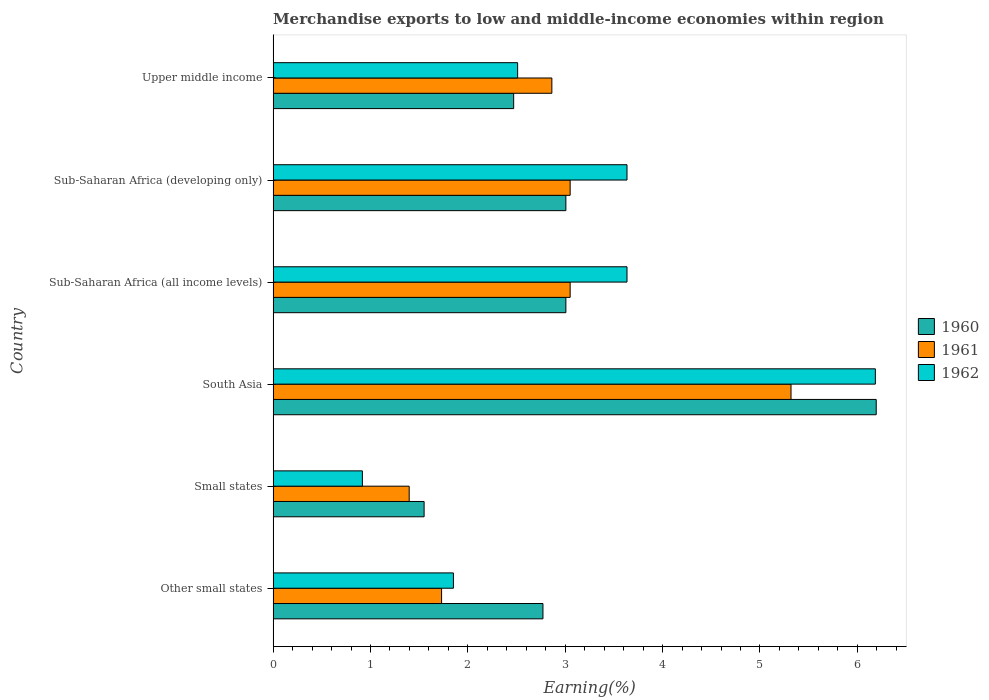How many groups of bars are there?
Your response must be concise. 6. What is the label of the 5th group of bars from the top?
Make the answer very short. Small states. What is the percentage of amount earned from merchandise exports in 1960 in Sub-Saharan Africa (all income levels)?
Offer a terse response. 3.01. Across all countries, what is the maximum percentage of amount earned from merchandise exports in 1961?
Offer a very short reply. 5.32. Across all countries, what is the minimum percentage of amount earned from merchandise exports in 1961?
Your response must be concise. 1.4. In which country was the percentage of amount earned from merchandise exports in 1961 minimum?
Your response must be concise. Small states. What is the total percentage of amount earned from merchandise exports in 1962 in the graph?
Your response must be concise. 18.73. What is the difference between the percentage of amount earned from merchandise exports in 1962 in Small states and that in Sub-Saharan Africa (developing only)?
Offer a terse response. -2.72. What is the difference between the percentage of amount earned from merchandise exports in 1962 in Upper middle income and the percentage of amount earned from merchandise exports in 1960 in Sub-Saharan Africa (all income levels)?
Keep it short and to the point. -0.5. What is the average percentage of amount earned from merchandise exports in 1961 per country?
Your answer should be compact. 2.9. What is the difference between the percentage of amount earned from merchandise exports in 1961 and percentage of amount earned from merchandise exports in 1960 in Other small states?
Provide a succinct answer. -1.04. What is the ratio of the percentage of amount earned from merchandise exports in 1960 in South Asia to that in Upper middle income?
Offer a very short reply. 2.51. Is the percentage of amount earned from merchandise exports in 1962 in Sub-Saharan Africa (all income levels) less than that in Sub-Saharan Africa (developing only)?
Offer a very short reply. No. Is the difference between the percentage of amount earned from merchandise exports in 1961 in South Asia and Sub-Saharan Africa (developing only) greater than the difference between the percentage of amount earned from merchandise exports in 1960 in South Asia and Sub-Saharan Africa (developing only)?
Your response must be concise. No. What is the difference between the highest and the second highest percentage of amount earned from merchandise exports in 1960?
Your response must be concise. 3.19. What is the difference between the highest and the lowest percentage of amount earned from merchandise exports in 1962?
Provide a succinct answer. 5.27. Is the sum of the percentage of amount earned from merchandise exports in 1962 in Other small states and Sub-Saharan Africa (developing only) greater than the maximum percentage of amount earned from merchandise exports in 1961 across all countries?
Ensure brevity in your answer.  Yes. What does the 2nd bar from the top in Other small states represents?
Your response must be concise. 1961. What does the 1st bar from the bottom in Sub-Saharan Africa (developing only) represents?
Give a very brief answer. 1960. Is it the case that in every country, the sum of the percentage of amount earned from merchandise exports in 1961 and percentage of amount earned from merchandise exports in 1962 is greater than the percentage of amount earned from merchandise exports in 1960?
Provide a short and direct response. Yes. Are all the bars in the graph horizontal?
Ensure brevity in your answer.  Yes. Does the graph contain any zero values?
Keep it short and to the point. No. Does the graph contain grids?
Make the answer very short. No. Where does the legend appear in the graph?
Provide a short and direct response. Center right. How many legend labels are there?
Provide a short and direct response. 3. How are the legend labels stacked?
Keep it short and to the point. Vertical. What is the title of the graph?
Offer a very short reply. Merchandise exports to low and middle-income economies within region. What is the label or title of the X-axis?
Provide a succinct answer. Earning(%). What is the label or title of the Y-axis?
Provide a succinct answer. Country. What is the Earning(%) in 1960 in Other small states?
Keep it short and to the point. 2.77. What is the Earning(%) in 1961 in Other small states?
Give a very brief answer. 1.73. What is the Earning(%) of 1962 in Other small states?
Your answer should be very brief. 1.85. What is the Earning(%) of 1960 in Small states?
Ensure brevity in your answer.  1.55. What is the Earning(%) in 1961 in Small states?
Ensure brevity in your answer.  1.4. What is the Earning(%) of 1962 in Small states?
Offer a very short reply. 0.92. What is the Earning(%) of 1960 in South Asia?
Offer a terse response. 6.19. What is the Earning(%) in 1961 in South Asia?
Make the answer very short. 5.32. What is the Earning(%) in 1962 in South Asia?
Provide a short and direct response. 6.19. What is the Earning(%) in 1960 in Sub-Saharan Africa (all income levels)?
Make the answer very short. 3.01. What is the Earning(%) of 1961 in Sub-Saharan Africa (all income levels)?
Ensure brevity in your answer.  3.05. What is the Earning(%) of 1962 in Sub-Saharan Africa (all income levels)?
Give a very brief answer. 3.63. What is the Earning(%) of 1960 in Sub-Saharan Africa (developing only)?
Your response must be concise. 3.01. What is the Earning(%) of 1961 in Sub-Saharan Africa (developing only)?
Provide a succinct answer. 3.05. What is the Earning(%) of 1962 in Sub-Saharan Africa (developing only)?
Provide a succinct answer. 3.63. What is the Earning(%) in 1960 in Upper middle income?
Offer a very short reply. 2.47. What is the Earning(%) of 1961 in Upper middle income?
Provide a short and direct response. 2.86. What is the Earning(%) of 1962 in Upper middle income?
Your response must be concise. 2.51. Across all countries, what is the maximum Earning(%) in 1960?
Keep it short and to the point. 6.19. Across all countries, what is the maximum Earning(%) in 1961?
Keep it short and to the point. 5.32. Across all countries, what is the maximum Earning(%) of 1962?
Provide a succinct answer. 6.19. Across all countries, what is the minimum Earning(%) in 1960?
Offer a very short reply. 1.55. Across all countries, what is the minimum Earning(%) of 1961?
Offer a very short reply. 1.4. Across all countries, what is the minimum Earning(%) of 1962?
Keep it short and to the point. 0.92. What is the total Earning(%) in 1960 in the graph?
Your response must be concise. 19. What is the total Earning(%) in 1961 in the graph?
Keep it short and to the point. 17.41. What is the total Earning(%) in 1962 in the graph?
Provide a succinct answer. 18.73. What is the difference between the Earning(%) of 1960 in Other small states and that in Small states?
Keep it short and to the point. 1.22. What is the difference between the Earning(%) in 1961 in Other small states and that in Small states?
Keep it short and to the point. 0.33. What is the difference between the Earning(%) in 1962 in Other small states and that in Small states?
Your answer should be compact. 0.94. What is the difference between the Earning(%) in 1960 in Other small states and that in South Asia?
Provide a short and direct response. -3.42. What is the difference between the Earning(%) of 1961 in Other small states and that in South Asia?
Provide a short and direct response. -3.59. What is the difference between the Earning(%) of 1962 in Other small states and that in South Asia?
Your answer should be very brief. -4.33. What is the difference between the Earning(%) of 1960 in Other small states and that in Sub-Saharan Africa (all income levels)?
Provide a short and direct response. -0.24. What is the difference between the Earning(%) of 1961 in Other small states and that in Sub-Saharan Africa (all income levels)?
Offer a very short reply. -1.32. What is the difference between the Earning(%) of 1962 in Other small states and that in Sub-Saharan Africa (all income levels)?
Provide a succinct answer. -1.78. What is the difference between the Earning(%) of 1960 in Other small states and that in Sub-Saharan Africa (developing only)?
Provide a succinct answer. -0.24. What is the difference between the Earning(%) of 1961 in Other small states and that in Sub-Saharan Africa (developing only)?
Your answer should be compact. -1.32. What is the difference between the Earning(%) in 1962 in Other small states and that in Sub-Saharan Africa (developing only)?
Make the answer very short. -1.78. What is the difference between the Earning(%) in 1960 in Other small states and that in Upper middle income?
Keep it short and to the point. 0.3. What is the difference between the Earning(%) of 1961 in Other small states and that in Upper middle income?
Provide a short and direct response. -1.13. What is the difference between the Earning(%) of 1962 in Other small states and that in Upper middle income?
Keep it short and to the point. -0.66. What is the difference between the Earning(%) of 1960 in Small states and that in South Asia?
Give a very brief answer. -4.64. What is the difference between the Earning(%) in 1961 in Small states and that in South Asia?
Make the answer very short. -3.92. What is the difference between the Earning(%) of 1962 in Small states and that in South Asia?
Your response must be concise. -5.27. What is the difference between the Earning(%) in 1960 in Small states and that in Sub-Saharan Africa (all income levels)?
Your answer should be compact. -1.46. What is the difference between the Earning(%) in 1961 in Small states and that in Sub-Saharan Africa (all income levels)?
Your answer should be compact. -1.65. What is the difference between the Earning(%) of 1962 in Small states and that in Sub-Saharan Africa (all income levels)?
Your answer should be very brief. -2.72. What is the difference between the Earning(%) of 1960 in Small states and that in Sub-Saharan Africa (developing only)?
Your answer should be compact. -1.46. What is the difference between the Earning(%) of 1961 in Small states and that in Sub-Saharan Africa (developing only)?
Ensure brevity in your answer.  -1.65. What is the difference between the Earning(%) of 1962 in Small states and that in Sub-Saharan Africa (developing only)?
Offer a terse response. -2.72. What is the difference between the Earning(%) in 1960 in Small states and that in Upper middle income?
Keep it short and to the point. -0.92. What is the difference between the Earning(%) in 1961 in Small states and that in Upper middle income?
Provide a succinct answer. -1.47. What is the difference between the Earning(%) of 1962 in Small states and that in Upper middle income?
Your response must be concise. -1.59. What is the difference between the Earning(%) of 1960 in South Asia and that in Sub-Saharan Africa (all income levels)?
Make the answer very short. 3.19. What is the difference between the Earning(%) in 1961 in South Asia and that in Sub-Saharan Africa (all income levels)?
Ensure brevity in your answer.  2.27. What is the difference between the Earning(%) in 1962 in South Asia and that in Sub-Saharan Africa (all income levels)?
Give a very brief answer. 2.55. What is the difference between the Earning(%) of 1960 in South Asia and that in Sub-Saharan Africa (developing only)?
Your answer should be very brief. 3.19. What is the difference between the Earning(%) of 1961 in South Asia and that in Sub-Saharan Africa (developing only)?
Keep it short and to the point. 2.27. What is the difference between the Earning(%) in 1962 in South Asia and that in Sub-Saharan Africa (developing only)?
Your answer should be compact. 2.55. What is the difference between the Earning(%) in 1960 in South Asia and that in Upper middle income?
Offer a terse response. 3.72. What is the difference between the Earning(%) in 1961 in South Asia and that in Upper middle income?
Offer a very short reply. 2.46. What is the difference between the Earning(%) of 1962 in South Asia and that in Upper middle income?
Your answer should be very brief. 3.67. What is the difference between the Earning(%) of 1960 in Sub-Saharan Africa (all income levels) and that in Sub-Saharan Africa (developing only)?
Give a very brief answer. 0. What is the difference between the Earning(%) in 1961 in Sub-Saharan Africa (all income levels) and that in Sub-Saharan Africa (developing only)?
Keep it short and to the point. 0. What is the difference between the Earning(%) in 1960 in Sub-Saharan Africa (all income levels) and that in Upper middle income?
Give a very brief answer. 0.54. What is the difference between the Earning(%) in 1961 in Sub-Saharan Africa (all income levels) and that in Upper middle income?
Offer a very short reply. 0.19. What is the difference between the Earning(%) in 1962 in Sub-Saharan Africa (all income levels) and that in Upper middle income?
Provide a succinct answer. 1.12. What is the difference between the Earning(%) of 1960 in Sub-Saharan Africa (developing only) and that in Upper middle income?
Your answer should be very brief. 0.54. What is the difference between the Earning(%) in 1961 in Sub-Saharan Africa (developing only) and that in Upper middle income?
Provide a short and direct response. 0.19. What is the difference between the Earning(%) in 1962 in Sub-Saharan Africa (developing only) and that in Upper middle income?
Offer a very short reply. 1.12. What is the difference between the Earning(%) of 1960 in Other small states and the Earning(%) of 1961 in Small states?
Your answer should be compact. 1.37. What is the difference between the Earning(%) of 1960 in Other small states and the Earning(%) of 1962 in Small states?
Your response must be concise. 1.85. What is the difference between the Earning(%) of 1961 in Other small states and the Earning(%) of 1962 in Small states?
Offer a very short reply. 0.81. What is the difference between the Earning(%) of 1960 in Other small states and the Earning(%) of 1961 in South Asia?
Give a very brief answer. -2.55. What is the difference between the Earning(%) in 1960 in Other small states and the Earning(%) in 1962 in South Asia?
Your answer should be compact. -3.41. What is the difference between the Earning(%) in 1961 in Other small states and the Earning(%) in 1962 in South Asia?
Offer a terse response. -4.46. What is the difference between the Earning(%) of 1960 in Other small states and the Earning(%) of 1961 in Sub-Saharan Africa (all income levels)?
Your answer should be compact. -0.28. What is the difference between the Earning(%) of 1960 in Other small states and the Earning(%) of 1962 in Sub-Saharan Africa (all income levels)?
Your response must be concise. -0.86. What is the difference between the Earning(%) in 1961 in Other small states and the Earning(%) in 1962 in Sub-Saharan Africa (all income levels)?
Your answer should be very brief. -1.9. What is the difference between the Earning(%) in 1960 in Other small states and the Earning(%) in 1961 in Sub-Saharan Africa (developing only)?
Provide a short and direct response. -0.28. What is the difference between the Earning(%) in 1960 in Other small states and the Earning(%) in 1962 in Sub-Saharan Africa (developing only)?
Your response must be concise. -0.86. What is the difference between the Earning(%) in 1961 in Other small states and the Earning(%) in 1962 in Sub-Saharan Africa (developing only)?
Your answer should be very brief. -1.9. What is the difference between the Earning(%) in 1960 in Other small states and the Earning(%) in 1961 in Upper middle income?
Your response must be concise. -0.09. What is the difference between the Earning(%) of 1960 in Other small states and the Earning(%) of 1962 in Upper middle income?
Your answer should be very brief. 0.26. What is the difference between the Earning(%) of 1961 in Other small states and the Earning(%) of 1962 in Upper middle income?
Offer a very short reply. -0.78. What is the difference between the Earning(%) in 1960 in Small states and the Earning(%) in 1961 in South Asia?
Provide a succinct answer. -3.77. What is the difference between the Earning(%) in 1960 in Small states and the Earning(%) in 1962 in South Asia?
Your response must be concise. -4.63. What is the difference between the Earning(%) in 1961 in Small states and the Earning(%) in 1962 in South Asia?
Ensure brevity in your answer.  -4.79. What is the difference between the Earning(%) in 1960 in Small states and the Earning(%) in 1961 in Sub-Saharan Africa (all income levels)?
Offer a very short reply. -1.5. What is the difference between the Earning(%) of 1960 in Small states and the Earning(%) of 1962 in Sub-Saharan Africa (all income levels)?
Your response must be concise. -2.08. What is the difference between the Earning(%) of 1961 in Small states and the Earning(%) of 1962 in Sub-Saharan Africa (all income levels)?
Give a very brief answer. -2.24. What is the difference between the Earning(%) of 1960 in Small states and the Earning(%) of 1961 in Sub-Saharan Africa (developing only)?
Give a very brief answer. -1.5. What is the difference between the Earning(%) of 1960 in Small states and the Earning(%) of 1962 in Sub-Saharan Africa (developing only)?
Provide a short and direct response. -2.08. What is the difference between the Earning(%) of 1961 in Small states and the Earning(%) of 1962 in Sub-Saharan Africa (developing only)?
Provide a short and direct response. -2.24. What is the difference between the Earning(%) in 1960 in Small states and the Earning(%) in 1961 in Upper middle income?
Provide a succinct answer. -1.31. What is the difference between the Earning(%) of 1960 in Small states and the Earning(%) of 1962 in Upper middle income?
Offer a very short reply. -0.96. What is the difference between the Earning(%) in 1961 in Small states and the Earning(%) in 1962 in Upper middle income?
Offer a very short reply. -1.11. What is the difference between the Earning(%) of 1960 in South Asia and the Earning(%) of 1961 in Sub-Saharan Africa (all income levels)?
Offer a very short reply. 3.14. What is the difference between the Earning(%) of 1960 in South Asia and the Earning(%) of 1962 in Sub-Saharan Africa (all income levels)?
Keep it short and to the point. 2.56. What is the difference between the Earning(%) in 1961 in South Asia and the Earning(%) in 1962 in Sub-Saharan Africa (all income levels)?
Your response must be concise. 1.68. What is the difference between the Earning(%) of 1960 in South Asia and the Earning(%) of 1961 in Sub-Saharan Africa (developing only)?
Provide a short and direct response. 3.14. What is the difference between the Earning(%) in 1960 in South Asia and the Earning(%) in 1962 in Sub-Saharan Africa (developing only)?
Your answer should be very brief. 2.56. What is the difference between the Earning(%) in 1961 in South Asia and the Earning(%) in 1962 in Sub-Saharan Africa (developing only)?
Your response must be concise. 1.68. What is the difference between the Earning(%) of 1960 in South Asia and the Earning(%) of 1961 in Upper middle income?
Your response must be concise. 3.33. What is the difference between the Earning(%) of 1960 in South Asia and the Earning(%) of 1962 in Upper middle income?
Your answer should be very brief. 3.68. What is the difference between the Earning(%) of 1961 in South Asia and the Earning(%) of 1962 in Upper middle income?
Offer a very short reply. 2.81. What is the difference between the Earning(%) in 1960 in Sub-Saharan Africa (all income levels) and the Earning(%) in 1961 in Sub-Saharan Africa (developing only)?
Your answer should be compact. -0.04. What is the difference between the Earning(%) in 1960 in Sub-Saharan Africa (all income levels) and the Earning(%) in 1962 in Sub-Saharan Africa (developing only)?
Make the answer very short. -0.63. What is the difference between the Earning(%) of 1961 in Sub-Saharan Africa (all income levels) and the Earning(%) of 1962 in Sub-Saharan Africa (developing only)?
Offer a terse response. -0.58. What is the difference between the Earning(%) in 1960 in Sub-Saharan Africa (all income levels) and the Earning(%) in 1961 in Upper middle income?
Your answer should be very brief. 0.14. What is the difference between the Earning(%) of 1960 in Sub-Saharan Africa (all income levels) and the Earning(%) of 1962 in Upper middle income?
Provide a short and direct response. 0.5. What is the difference between the Earning(%) of 1961 in Sub-Saharan Africa (all income levels) and the Earning(%) of 1962 in Upper middle income?
Ensure brevity in your answer.  0.54. What is the difference between the Earning(%) in 1960 in Sub-Saharan Africa (developing only) and the Earning(%) in 1961 in Upper middle income?
Your response must be concise. 0.14. What is the difference between the Earning(%) of 1960 in Sub-Saharan Africa (developing only) and the Earning(%) of 1962 in Upper middle income?
Keep it short and to the point. 0.5. What is the difference between the Earning(%) of 1961 in Sub-Saharan Africa (developing only) and the Earning(%) of 1962 in Upper middle income?
Provide a short and direct response. 0.54. What is the average Earning(%) in 1960 per country?
Ensure brevity in your answer.  3.17. What is the average Earning(%) of 1961 per country?
Your answer should be very brief. 2.9. What is the average Earning(%) in 1962 per country?
Your response must be concise. 3.12. What is the difference between the Earning(%) of 1960 and Earning(%) of 1961 in Other small states?
Keep it short and to the point. 1.04. What is the difference between the Earning(%) in 1960 and Earning(%) in 1962 in Other small states?
Ensure brevity in your answer.  0.92. What is the difference between the Earning(%) in 1961 and Earning(%) in 1962 in Other small states?
Offer a very short reply. -0.12. What is the difference between the Earning(%) of 1960 and Earning(%) of 1961 in Small states?
Your answer should be very brief. 0.15. What is the difference between the Earning(%) of 1960 and Earning(%) of 1962 in Small states?
Give a very brief answer. 0.63. What is the difference between the Earning(%) of 1961 and Earning(%) of 1962 in Small states?
Your answer should be very brief. 0.48. What is the difference between the Earning(%) of 1960 and Earning(%) of 1961 in South Asia?
Provide a succinct answer. 0.88. What is the difference between the Earning(%) of 1960 and Earning(%) of 1962 in South Asia?
Your response must be concise. 0.01. What is the difference between the Earning(%) in 1961 and Earning(%) in 1962 in South Asia?
Keep it short and to the point. -0.87. What is the difference between the Earning(%) of 1960 and Earning(%) of 1961 in Sub-Saharan Africa (all income levels)?
Give a very brief answer. -0.04. What is the difference between the Earning(%) of 1960 and Earning(%) of 1962 in Sub-Saharan Africa (all income levels)?
Provide a short and direct response. -0.63. What is the difference between the Earning(%) of 1961 and Earning(%) of 1962 in Sub-Saharan Africa (all income levels)?
Make the answer very short. -0.58. What is the difference between the Earning(%) in 1960 and Earning(%) in 1961 in Sub-Saharan Africa (developing only)?
Your answer should be very brief. -0.04. What is the difference between the Earning(%) of 1960 and Earning(%) of 1962 in Sub-Saharan Africa (developing only)?
Ensure brevity in your answer.  -0.63. What is the difference between the Earning(%) in 1961 and Earning(%) in 1962 in Sub-Saharan Africa (developing only)?
Your answer should be very brief. -0.58. What is the difference between the Earning(%) in 1960 and Earning(%) in 1961 in Upper middle income?
Your response must be concise. -0.39. What is the difference between the Earning(%) of 1960 and Earning(%) of 1962 in Upper middle income?
Provide a short and direct response. -0.04. What is the difference between the Earning(%) in 1961 and Earning(%) in 1962 in Upper middle income?
Your answer should be compact. 0.35. What is the ratio of the Earning(%) in 1960 in Other small states to that in Small states?
Make the answer very short. 1.79. What is the ratio of the Earning(%) in 1961 in Other small states to that in Small states?
Your answer should be very brief. 1.24. What is the ratio of the Earning(%) in 1962 in Other small states to that in Small states?
Give a very brief answer. 2.02. What is the ratio of the Earning(%) of 1960 in Other small states to that in South Asia?
Offer a terse response. 0.45. What is the ratio of the Earning(%) of 1961 in Other small states to that in South Asia?
Keep it short and to the point. 0.33. What is the ratio of the Earning(%) in 1962 in Other small states to that in South Asia?
Your response must be concise. 0.3. What is the ratio of the Earning(%) in 1960 in Other small states to that in Sub-Saharan Africa (all income levels)?
Give a very brief answer. 0.92. What is the ratio of the Earning(%) of 1961 in Other small states to that in Sub-Saharan Africa (all income levels)?
Your answer should be compact. 0.57. What is the ratio of the Earning(%) in 1962 in Other small states to that in Sub-Saharan Africa (all income levels)?
Provide a succinct answer. 0.51. What is the ratio of the Earning(%) in 1960 in Other small states to that in Sub-Saharan Africa (developing only)?
Offer a terse response. 0.92. What is the ratio of the Earning(%) of 1961 in Other small states to that in Sub-Saharan Africa (developing only)?
Make the answer very short. 0.57. What is the ratio of the Earning(%) in 1962 in Other small states to that in Sub-Saharan Africa (developing only)?
Give a very brief answer. 0.51. What is the ratio of the Earning(%) of 1960 in Other small states to that in Upper middle income?
Keep it short and to the point. 1.12. What is the ratio of the Earning(%) of 1961 in Other small states to that in Upper middle income?
Provide a succinct answer. 0.6. What is the ratio of the Earning(%) of 1962 in Other small states to that in Upper middle income?
Your answer should be very brief. 0.74. What is the ratio of the Earning(%) of 1960 in Small states to that in South Asia?
Offer a terse response. 0.25. What is the ratio of the Earning(%) of 1961 in Small states to that in South Asia?
Ensure brevity in your answer.  0.26. What is the ratio of the Earning(%) of 1962 in Small states to that in South Asia?
Provide a short and direct response. 0.15. What is the ratio of the Earning(%) of 1960 in Small states to that in Sub-Saharan Africa (all income levels)?
Give a very brief answer. 0.52. What is the ratio of the Earning(%) of 1961 in Small states to that in Sub-Saharan Africa (all income levels)?
Provide a short and direct response. 0.46. What is the ratio of the Earning(%) of 1962 in Small states to that in Sub-Saharan Africa (all income levels)?
Keep it short and to the point. 0.25. What is the ratio of the Earning(%) in 1960 in Small states to that in Sub-Saharan Africa (developing only)?
Your response must be concise. 0.52. What is the ratio of the Earning(%) of 1961 in Small states to that in Sub-Saharan Africa (developing only)?
Ensure brevity in your answer.  0.46. What is the ratio of the Earning(%) in 1962 in Small states to that in Sub-Saharan Africa (developing only)?
Offer a very short reply. 0.25. What is the ratio of the Earning(%) in 1960 in Small states to that in Upper middle income?
Ensure brevity in your answer.  0.63. What is the ratio of the Earning(%) of 1961 in Small states to that in Upper middle income?
Ensure brevity in your answer.  0.49. What is the ratio of the Earning(%) in 1962 in Small states to that in Upper middle income?
Give a very brief answer. 0.36. What is the ratio of the Earning(%) in 1960 in South Asia to that in Sub-Saharan Africa (all income levels)?
Provide a short and direct response. 2.06. What is the ratio of the Earning(%) in 1961 in South Asia to that in Sub-Saharan Africa (all income levels)?
Make the answer very short. 1.74. What is the ratio of the Earning(%) in 1962 in South Asia to that in Sub-Saharan Africa (all income levels)?
Your answer should be very brief. 1.7. What is the ratio of the Earning(%) of 1960 in South Asia to that in Sub-Saharan Africa (developing only)?
Your response must be concise. 2.06. What is the ratio of the Earning(%) of 1961 in South Asia to that in Sub-Saharan Africa (developing only)?
Keep it short and to the point. 1.74. What is the ratio of the Earning(%) of 1962 in South Asia to that in Sub-Saharan Africa (developing only)?
Give a very brief answer. 1.7. What is the ratio of the Earning(%) of 1960 in South Asia to that in Upper middle income?
Your answer should be very brief. 2.51. What is the ratio of the Earning(%) of 1961 in South Asia to that in Upper middle income?
Your response must be concise. 1.86. What is the ratio of the Earning(%) of 1962 in South Asia to that in Upper middle income?
Provide a succinct answer. 2.46. What is the ratio of the Earning(%) in 1961 in Sub-Saharan Africa (all income levels) to that in Sub-Saharan Africa (developing only)?
Make the answer very short. 1. What is the ratio of the Earning(%) of 1962 in Sub-Saharan Africa (all income levels) to that in Sub-Saharan Africa (developing only)?
Ensure brevity in your answer.  1. What is the ratio of the Earning(%) of 1960 in Sub-Saharan Africa (all income levels) to that in Upper middle income?
Give a very brief answer. 1.22. What is the ratio of the Earning(%) in 1961 in Sub-Saharan Africa (all income levels) to that in Upper middle income?
Your answer should be very brief. 1.07. What is the ratio of the Earning(%) in 1962 in Sub-Saharan Africa (all income levels) to that in Upper middle income?
Offer a terse response. 1.45. What is the ratio of the Earning(%) of 1960 in Sub-Saharan Africa (developing only) to that in Upper middle income?
Your answer should be very brief. 1.22. What is the ratio of the Earning(%) in 1961 in Sub-Saharan Africa (developing only) to that in Upper middle income?
Give a very brief answer. 1.07. What is the ratio of the Earning(%) in 1962 in Sub-Saharan Africa (developing only) to that in Upper middle income?
Your answer should be compact. 1.45. What is the difference between the highest and the second highest Earning(%) in 1960?
Make the answer very short. 3.19. What is the difference between the highest and the second highest Earning(%) in 1961?
Provide a succinct answer. 2.27. What is the difference between the highest and the second highest Earning(%) in 1962?
Your response must be concise. 2.55. What is the difference between the highest and the lowest Earning(%) in 1960?
Give a very brief answer. 4.64. What is the difference between the highest and the lowest Earning(%) of 1961?
Offer a very short reply. 3.92. What is the difference between the highest and the lowest Earning(%) in 1962?
Your answer should be very brief. 5.27. 